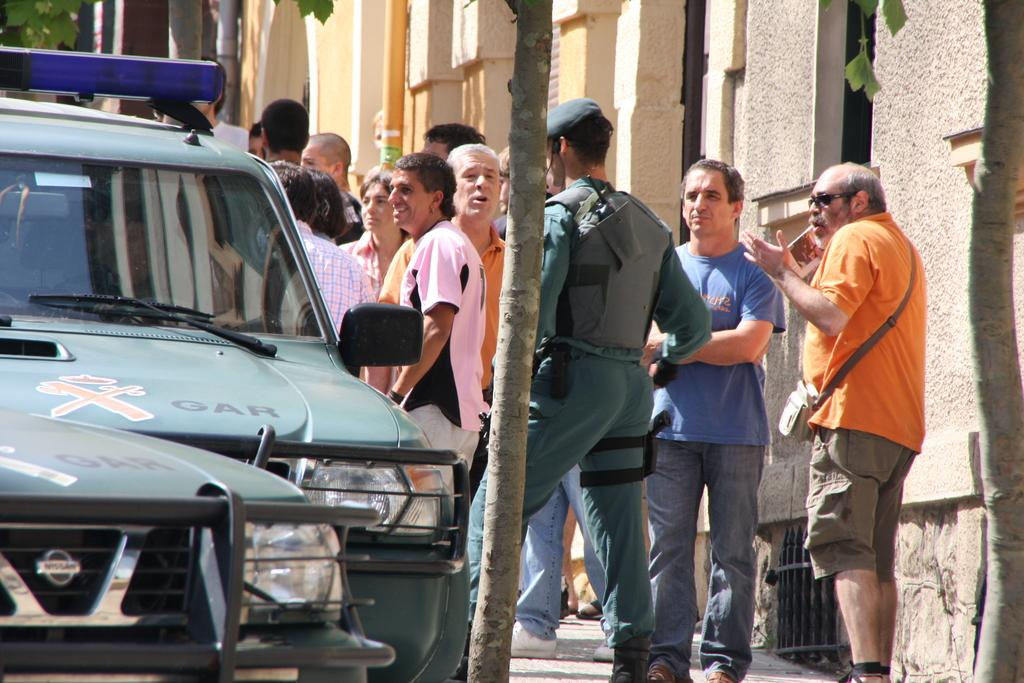How many vehicles can be seen in the image? There are two vehicles in the image. What else is present in the image besides the vehicles? There is a tree, people standing on the ground, pipes, and buildings in the background. Can you describe the location of the tree in the image? The tree is in the image, but its exact location is not specified. What type of structures can be seen in the background of the image? There are buildings in the background of the image. What type of star can be seen shining in the image? There is no star visible in the image; it features vehicles, a tree, people, pipes, and buildings. What song is being played in the background of the image? There is no mention of any music or song in the image; it only shows vehicles, a tree, people, pipes, and buildings. 